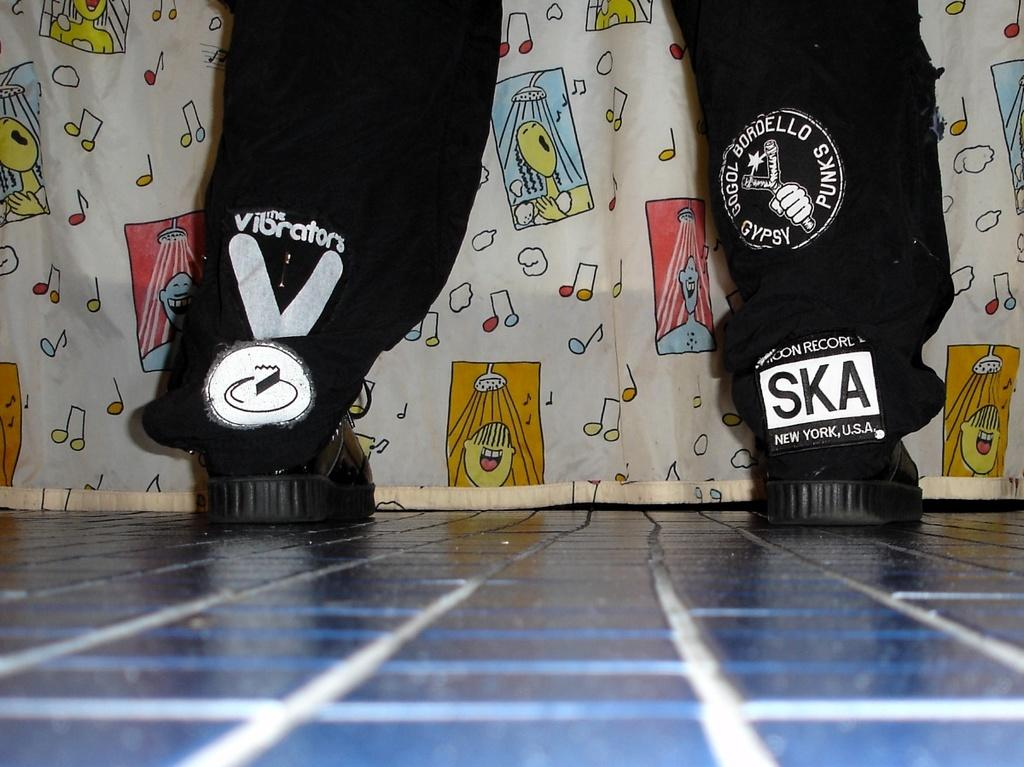What part of a person's body is visible in the image? There is a person's legs visible in the image. Where are the person's legs located? The person's legs are on the floor. What can be seen in the background of the image? There is a cloth present in the background of the image. What type of memory is the person using to recall their camp experience in the image? There is no indication in the image that the person is recalling a camp experience or using any type of memory. 